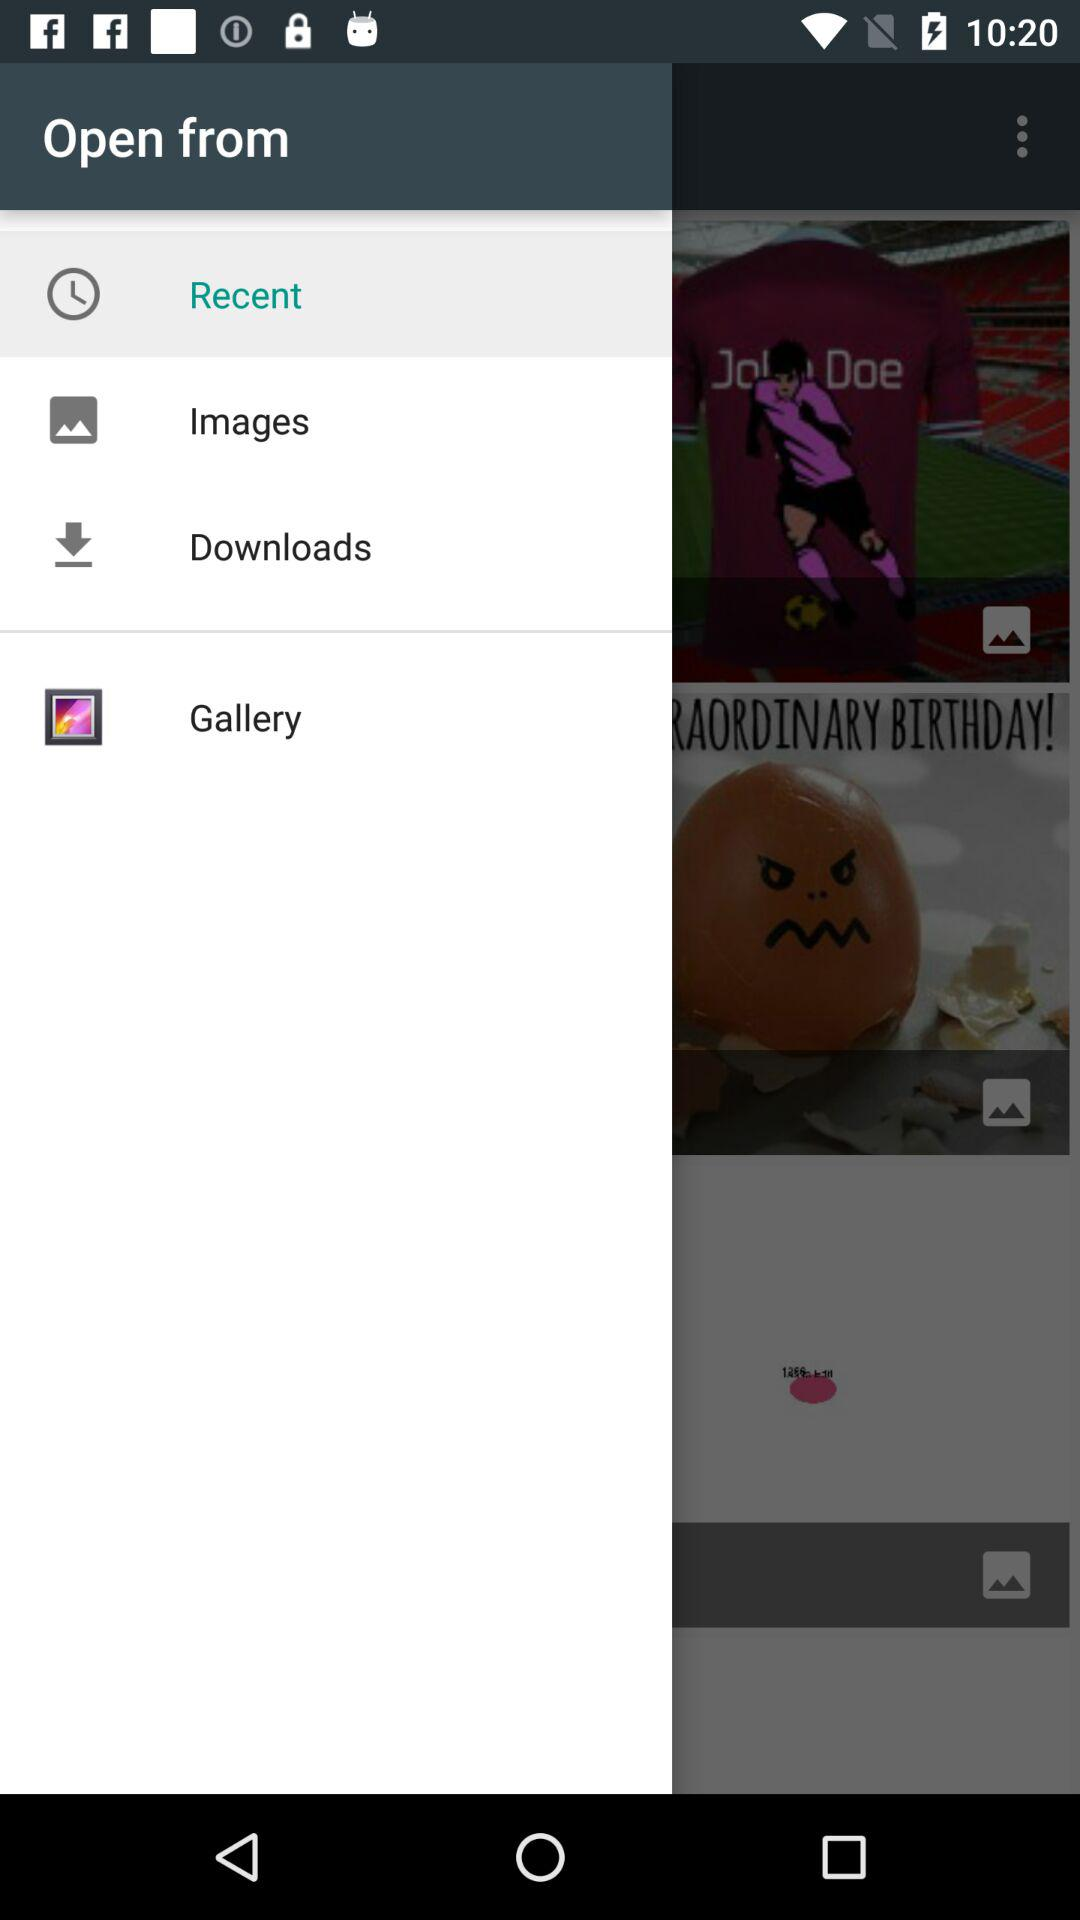Which folder is selected in "Open From"? The selected folder is "Recent". 